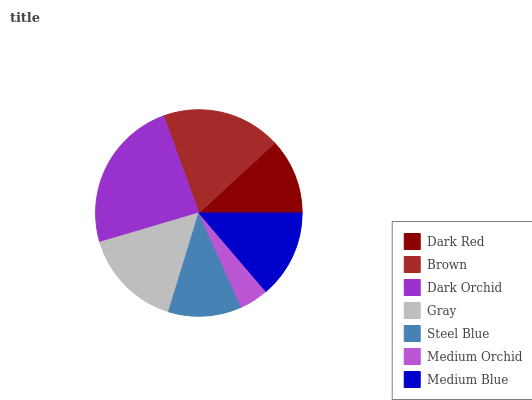Is Medium Orchid the minimum?
Answer yes or no. Yes. Is Dark Orchid the maximum?
Answer yes or no. Yes. Is Brown the minimum?
Answer yes or no. No. Is Brown the maximum?
Answer yes or no. No. Is Brown greater than Dark Red?
Answer yes or no. Yes. Is Dark Red less than Brown?
Answer yes or no. Yes. Is Dark Red greater than Brown?
Answer yes or no. No. Is Brown less than Dark Red?
Answer yes or no. No. Is Medium Blue the high median?
Answer yes or no. Yes. Is Medium Blue the low median?
Answer yes or no. Yes. Is Medium Orchid the high median?
Answer yes or no. No. Is Steel Blue the low median?
Answer yes or no. No. 